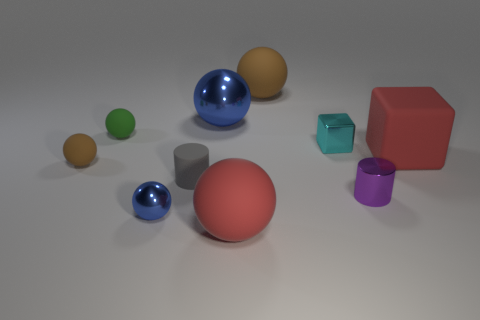How many blue balls must be subtracted to get 1 blue balls? 1 Subtract all metal balls. How many balls are left? 4 Subtract all green balls. How many balls are left? 5 Subtract all red balls. Subtract all yellow cubes. How many balls are left? 5 Subtract all blocks. How many objects are left? 8 Add 5 red rubber blocks. How many red rubber blocks exist? 6 Subtract 0 cyan spheres. How many objects are left? 10 Subtract all tiny gray rubber things. Subtract all green matte things. How many objects are left? 8 Add 5 large blue things. How many large blue things are left? 6 